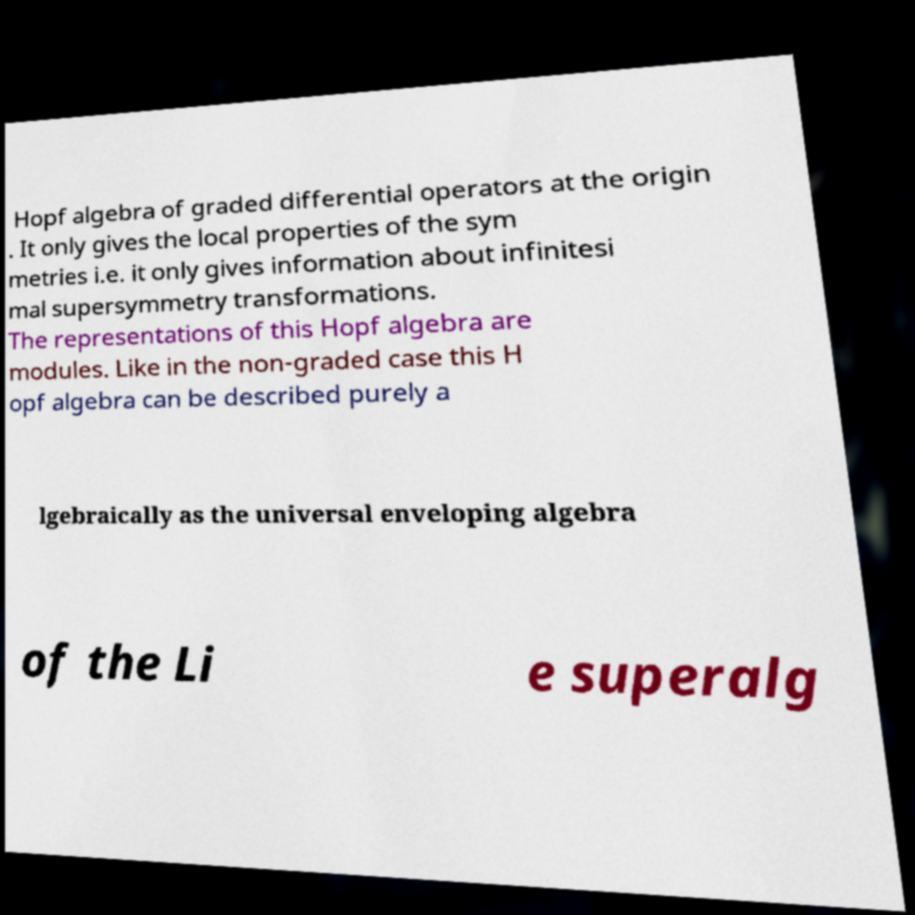There's text embedded in this image that I need extracted. Can you transcribe it verbatim? Hopf algebra of graded differential operators at the origin . It only gives the local properties of the sym metries i.e. it only gives information about infinitesi mal supersymmetry transformations. The representations of this Hopf algebra are modules. Like in the non-graded case this H opf algebra can be described purely a lgebraically as the universal enveloping algebra of the Li e superalg 